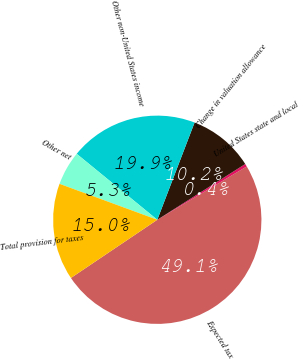Convert chart. <chart><loc_0><loc_0><loc_500><loc_500><pie_chart><fcel>Expected tax<fcel>United States state and local<fcel>Change in valuation allowance<fcel>Other non-United States income<fcel>Other net<fcel>Total provision for taxes<nl><fcel>49.11%<fcel>0.44%<fcel>10.18%<fcel>19.91%<fcel>5.31%<fcel>15.04%<nl></chart> 